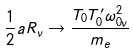<formula> <loc_0><loc_0><loc_500><loc_500>\frac { 1 } { 2 } a R _ { \nu } \rightarrow \frac { T _ { 0 } T ^ { \prime } _ { 0 } \omega ^ { 2 } _ { 0 \nu } } { m _ { e } }</formula> 